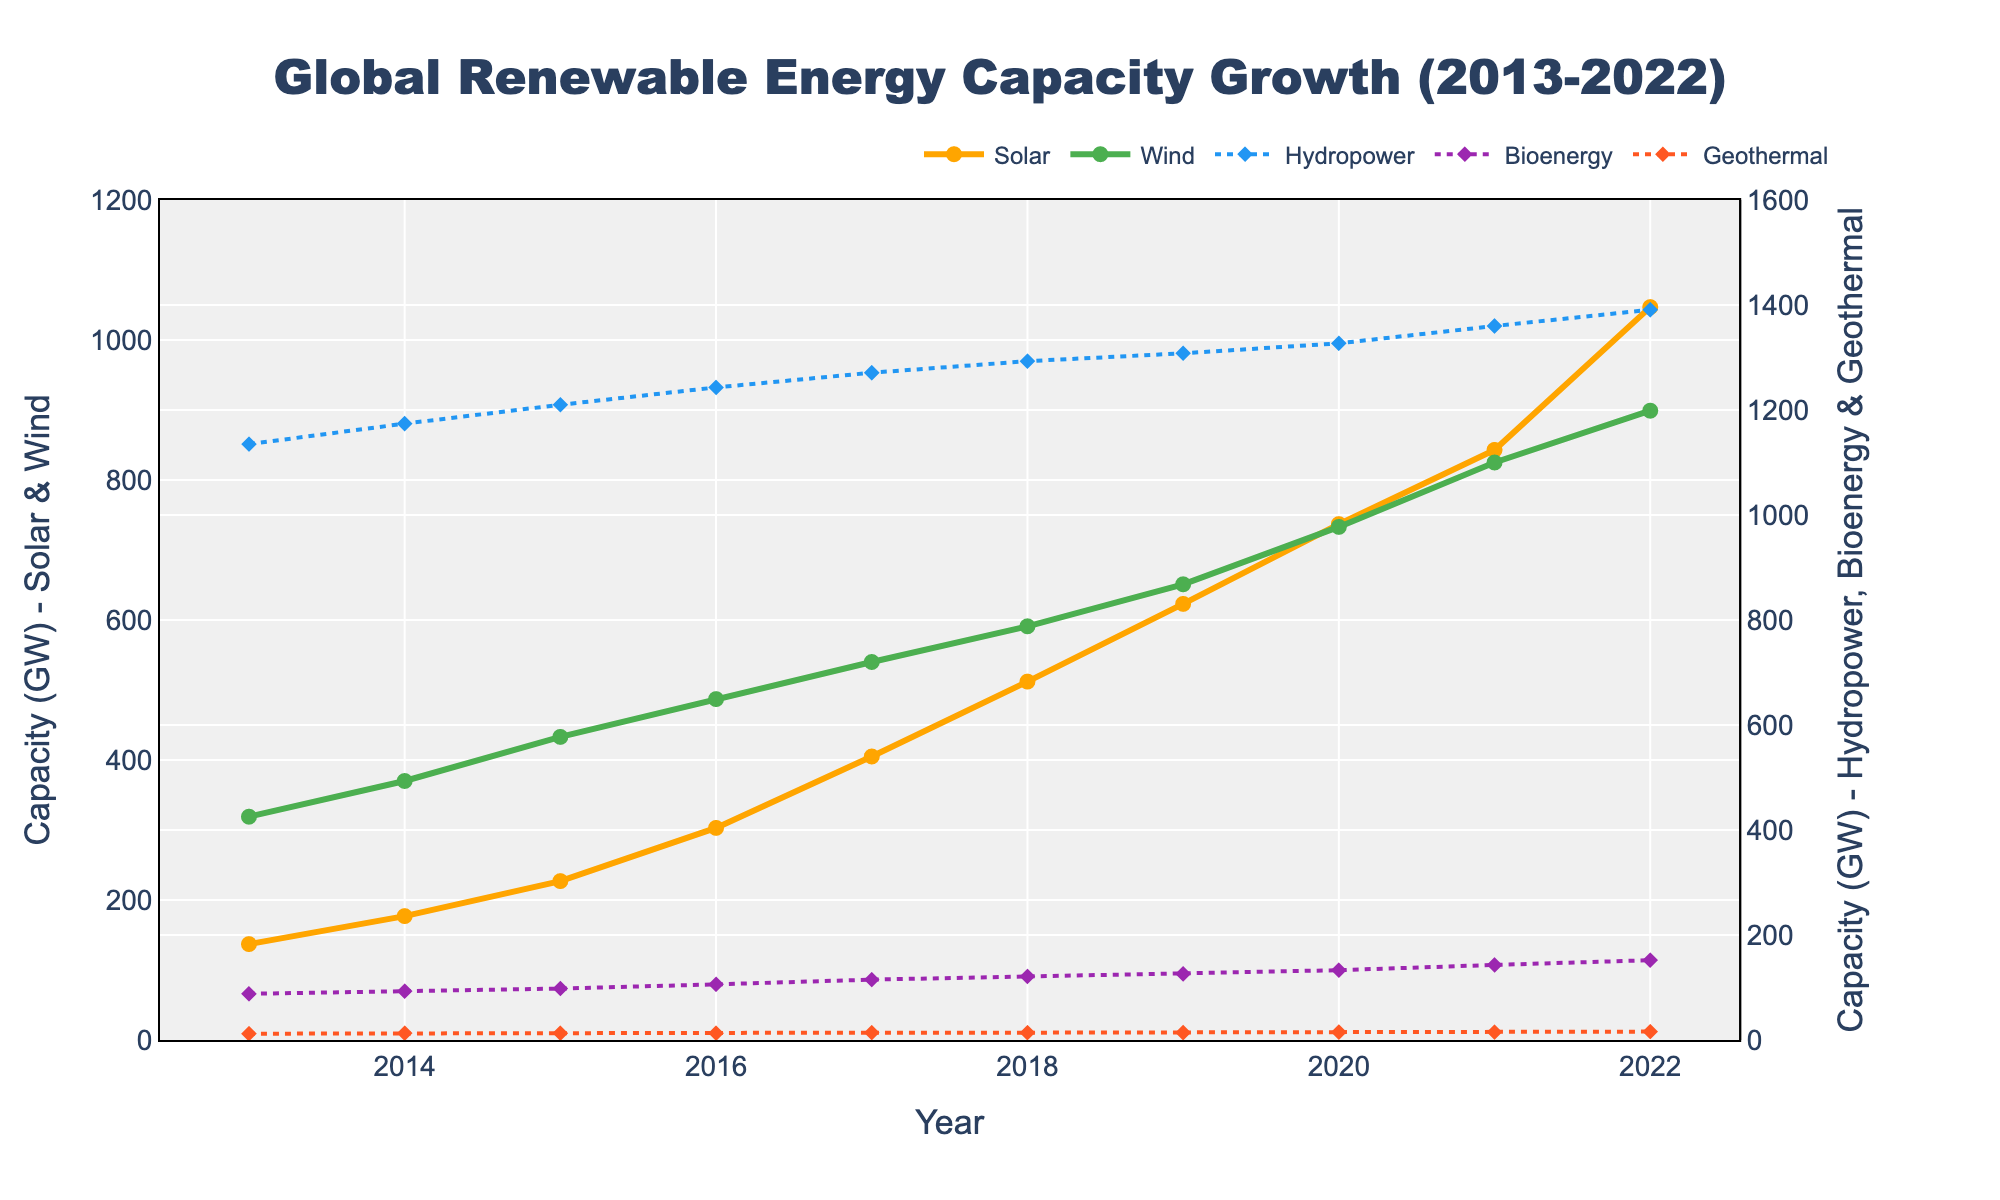What is the total global renewable energy capacity for Solar and Wind in 2022? To determine the total global renewable energy capacity for Solar and Wind in 2022, sum the capacities of Solar and Wind from the given data for the year 2022. The capacities are Solar: 1047 GW and Wind: 899 GW. Therefore, the total capacity is 1047 + 899 = 1946 GW.
Answer: 1946 GW Which energy source had the greatest increase in capacity between 2013 and 2022? Calculate the increase in capacity for each energy source by subtracting their 2013 values from their 2022 values. Solar: 1047 - 137 = 910 GW, Wind: 899 - 319 = 580 GW, Hydropower: 1391 - 1135 = 256 GW, Bioenergy: 152 - 88 = 64 GW, Geothermal: 16 - 12 = 4 GW. The greatest increase is in Solar with 910 GW.
Answer: Solar Compare the capacity of Solar energy in 2016 with Wind energy in 2016. Which one is higher and by how much? From the data, Solar capacity in 2016 is 303 GW and Wind capacity in 2016 is 487 GW. The difference is 487 - 303 = 184 GW, with Wind being higher.
Answer: Wind by 184 GW What was the average annual growth rate of Bioenergy between 2013 and 2022? First, find the total increase in Bioenergy from 2013 to 2022, which is 152 - 88 = 64 GW. The number of years is 2022 - 2013 = 9 years. The average annual growth rate is 64 GW / 9 years = 7.11 GW/year.
Answer: 7.11 GW/year How did the growth in Hydropower capacity compare to Bioenergy capacity in the period from 2017 to 2022? Calculate the increment for both sources. Hydropower: 1391 - 1271 = 120 GW, Bioenergy: 152 - 115 = 37 GW. Hydropower had a significantly greater increase compared to Bioenergy.
Answer: Hydropower increased more by 83 GW Looking at the visual markers, which energy sources are represented by solid lines and thicker markers? From the visual description, Solar and Wind have solid lines and are represented by thicker markers (size 8 and circle symbol).
Answer: Solar and Wind In what year did Wind energy surpass a capacity of 500 GW, and what was its value that year? By examining the Wind capacity over the years, in 2017 Wind capacity is 540 GW, which is the first year it surpassed 500 GW.
Answer: 2017, 540 GW What is the range of capacities for Geothermal energy from 2013 to 2022? From the data, the minimum value is 12 GW in 2013 and the maximum value is 16 GW in 2022. Therefore, the range is 16 - 12 = 4 GW.
Answer: 4 GW If you combine the capacities of Bioenergy and Geothermal in 2015, does their sum exceed the Hydropower capacity in the same year? Add Bioenergy (98 GW) and Geothermal (13 GW) in 2015, which gives 98 + 13 = 111 GW. Hydropower in 2015 is 1210 GW. 111 GW does not exceed 1210 GW.
Answer: No What trend can you observe for Solar energy capacity growth compared to Hydropower over the decade? Solar energy shows a steep and consistent growth trend, rising from 137 GW in 2013 to 1047 GW in 2022. In contrast, Hydropower grows more slowly from 1135 GW in 2013 to 1391 GW in 2022.
Answer: Solar has a steep growth, Hydropower grows slowly 